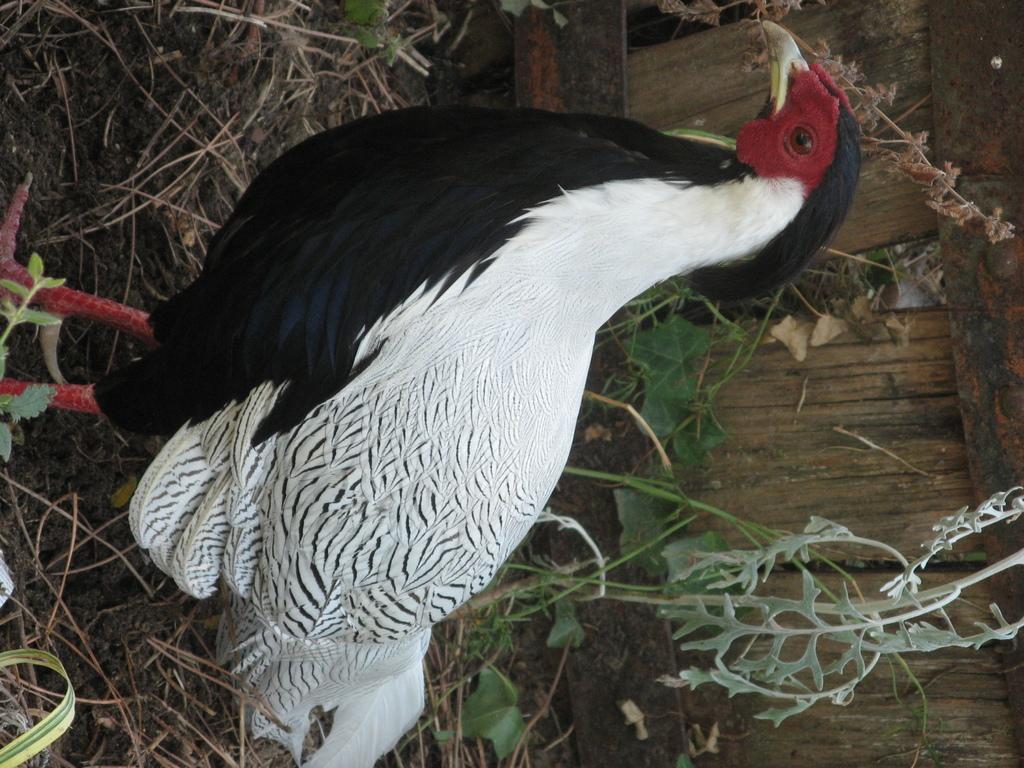How would you summarize this image in a sentence or two? This image is in right direction. Here I can see a hen. In the background there are plants and dry grass on the ground. On the right side there is a wooden plank. 